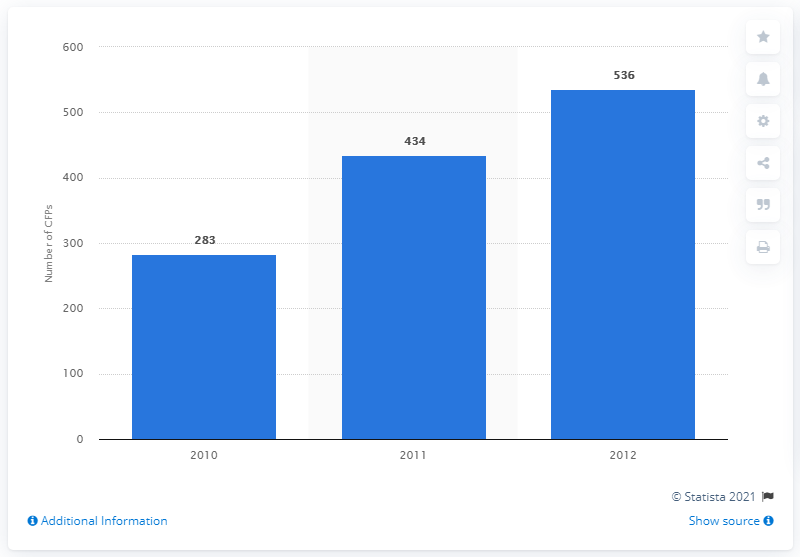Highlight a few significant elements in this photo. In 2011, there were 434 crowdfunding platforms. 